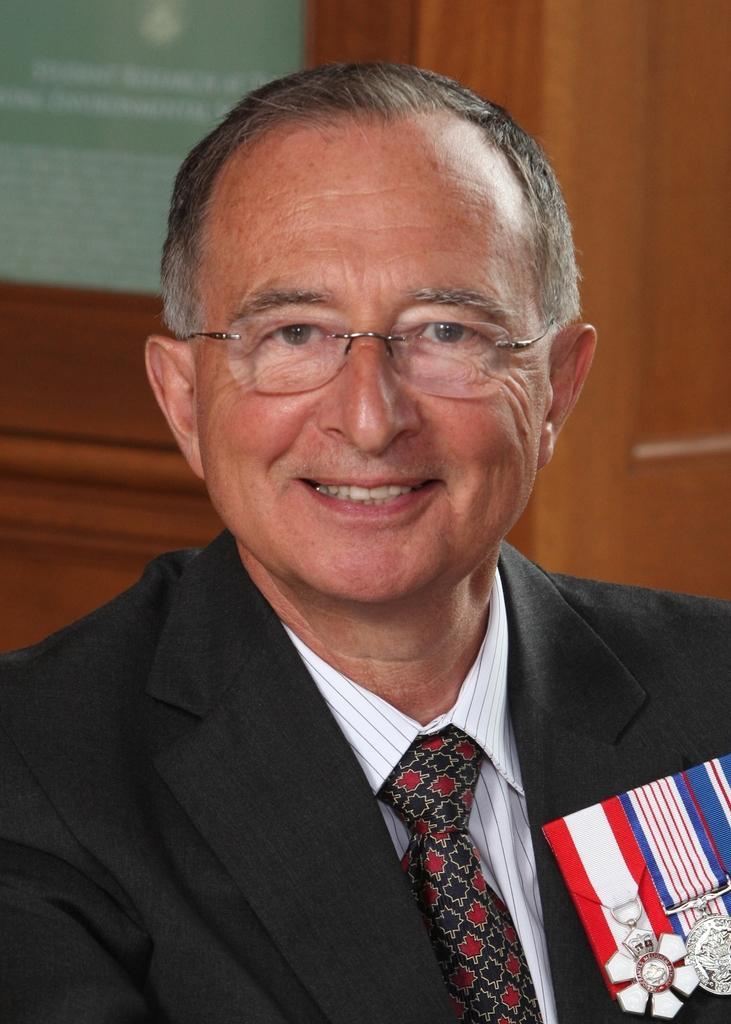How would you summarize this image in a sentence or two? In the center of the image there is a person wearing a suit with badges. In the background of the image there is a wooden door. 